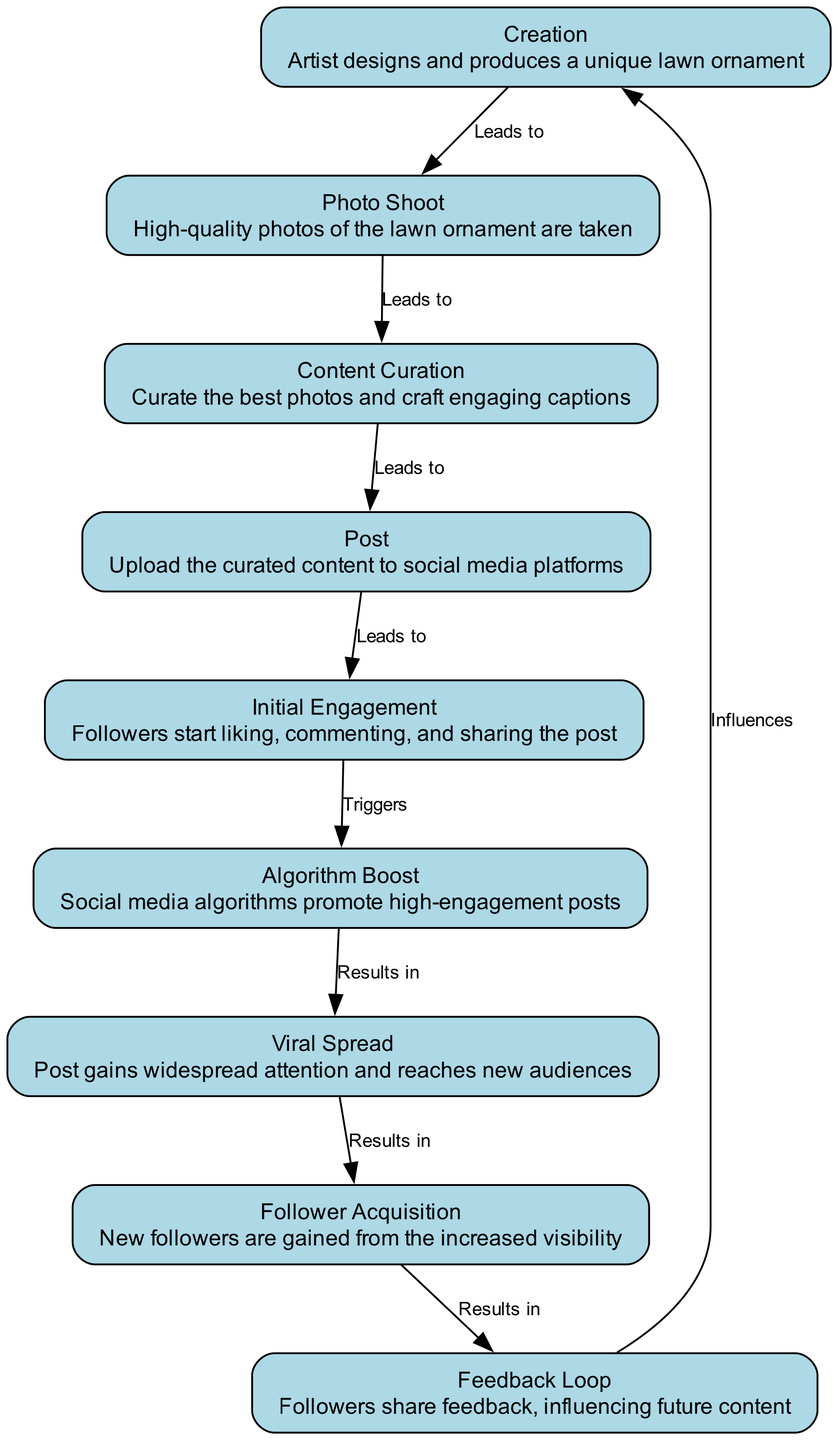What's the first step in the lifecycle? The diagram shows that the first node is "Creation", indicating that the lifecycle starts when the artist designs and produces a unique lawn ornament.
Answer: Creation How many nodes are there in the diagram? By counting the nodes listed in the data, there are a total of nine distinct nodes representing different stages of the lifecycle.
Answer: 9 What is the relationship between 'Post' and 'Initial Engagement'? The edge from 'Post' to 'Initial Engagement' is labeled "Leads to", indicating that posting leads to initial engagement from followers.
Answer: Leads to Which stage triggers algorithm boost? The edge from 'Initial Engagement' to 'Algorithm Boost' is labeled "Triggers", meaning initial engagement triggers the algorithm boost.
Answer: Initial Engagement What results from viral spread? The diagram indicates that the viral spread results in 'Follower Acquisition', which means gaining new followers due to increased visibility.
Answer: Follower Acquisition How does follower acquisition influence future content? The diagram shows that 'Follower Acquisition' leads to 'Feedback Loop', indicating that gaining followers influences the feedback shared about the content.
Answer: Feedback Loop What is the last step in the lifecycle? The last node in the sequence is 'Feedback Loop', which feeds back into the 'Creation' phase, indicating the cycle continues as feedback influences future designs.
Answer: Feedback Loop What type of post results in an algorithm boost? The diagram illustrates that 'Initial Engagement', which includes liking, commenting, and sharing, leads to an algorithm boost.
Answer: High-engagement posts Which two stages directly connect with an edge labeled "Results in"? The edge labeled "Results in" connects 'Viral Spread' to 'Follower Acquisition' and 'Follower Acquisition' to 'Feedback Loop', indicating both are crucial outcomes of viral content.
Answer: Viral Spread and Follower Acquisition 